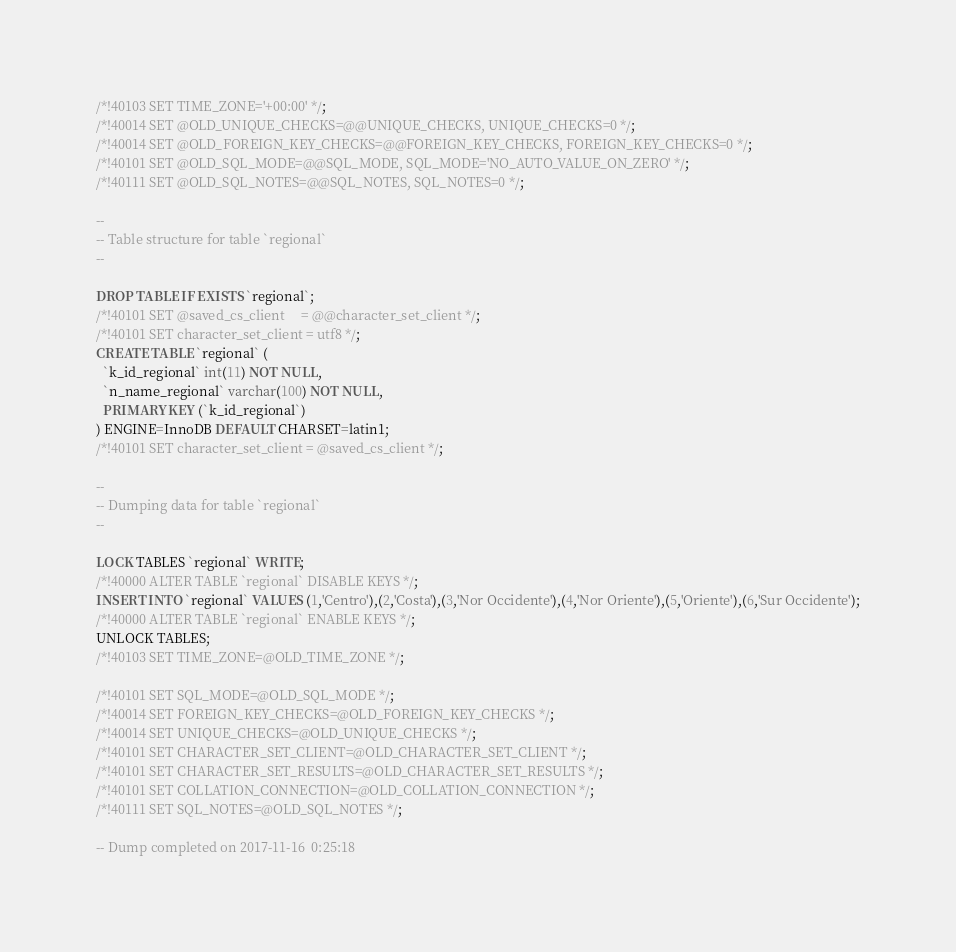Convert code to text. <code><loc_0><loc_0><loc_500><loc_500><_SQL_>/*!40103 SET TIME_ZONE='+00:00' */;
/*!40014 SET @OLD_UNIQUE_CHECKS=@@UNIQUE_CHECKS, UNIQUE_CHECKS=0 */;
/*!40014 SET @OLD_FOREIGN_KEY_CHECKS=@@FOREIGN_KEY_CHECKS, FOREIGN_KEY_CHECKS=0 */;
/*!40101 SET @OLD_SQL_MODE=@@SQL_MODE, SQL_MODE='NO_AUTO_VALUE_ON_ZERO' */;
/*!40111 SET @OLD_SQL_NOTES=@@SQL_NOTES, SQL_NOTES=0 */;

--
-- Table structure for table `regional`
--

DROP TABLE IF EXISTS `regional`;
/*!40101 SET @saved_cs_client     = @@character_set_client */;
/*!40101 SET character_set_client = utf8 */;
CREATE TABLE `regional` (
  `k_id_regional` int(11) NOT NULL,
  `n_name_regional` varchar(100) NOT NULL,
  PRIMARY KEY (`k_id_regional`)
) ENGINE=InnoDB DEFAULT CHARSET=latin1;
/*!40101 SET character_set_client = @saved_cs_client */;

--
-- Dumping data for table `regional`
--

LOCK TABLES `regional` WRITE;
/*!40000 ALTER TABLE `regional` DISABLE KEYS */;
INSERT INTO `regional` VALUES (1,'Centro'),(2,'Costa'),(3,'Nor Occidente'),(4,'Nor Oriente'),(5,'Oriente'),(6,'Sur Occidente');
/*!40000 ALTER TABLE `regional` ENABLE KEYS */;
UNLOCK TABLES;
/*!40103 SET TIME_ZONE=@OLD_TIME_ZONE */;

/*!40101 SET SQL_MODE=@OLD_SQL_MODE */;
/*!40014 SET FOREIGN_KEY_CHECKS=@OLD_FOREIGN_KEY_CHECKS */;
/*!40014 SET UNIQUE_CHECKS=@OLD_UNIQUE_CHECKS */;
/*!40101 SET CHARACTER_SET_CLIENT=@OLD_CHARACTER_SET_CLIENT */;
/*!40101 SET CHARACTER_SET_RESULTS=@OLD_CHARACTER_SET_RESULTS */;
/*!40101 SET COLLATION_CONNECTION=@OLD_COLLATION_CONNECTION */;
/*!40111 SET SQL_NOTES=@OLD_SQL_NOTES */;

-- Dump completed on 2017-11-16  0:25:18
</code> 